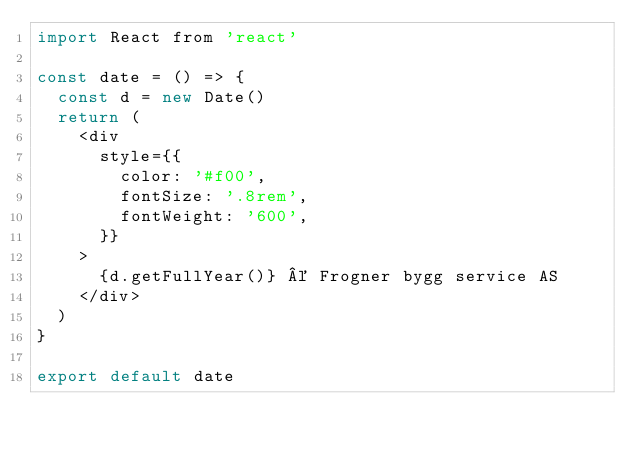Convert code to text. <code><loc_0><loc_0><loc_500><loc_500><_JavaScript_>import React from 'react'

const date = () => {
	const d = new Date()
	return (
		<div
			style={{
				color: '#f00',
				fontSize: '.8rem',
				fontWeight: '600',
			}}
		>
			{d.getFullYear()} © Frogner bygg service AS
		</div>
	)
}

export default date
</code> 